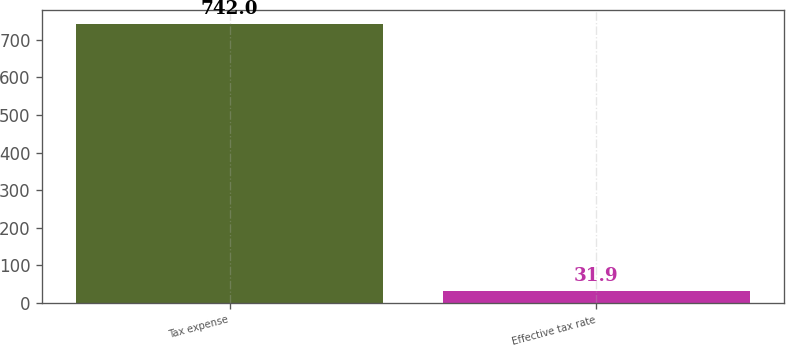Convert chart to OTSL. <chart><loc_0><loc_0><loc_500><loc_500><bar_chart><fcel>Tax expense<fcel>Effective tax rate<nl><fcel>742<fcel>31.9<nl></chart> 